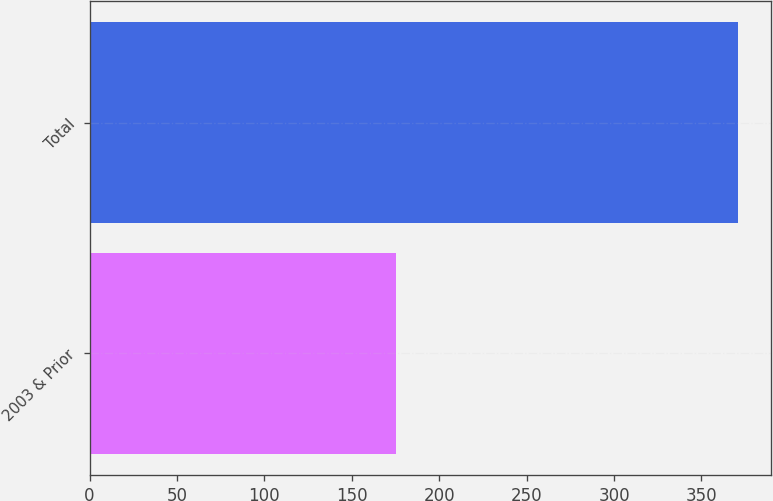<chart> <loc_0><loc_0><loc_500><loc_500><bar_chart><fcel>2003 & Prior<fcel>Total<nl><fcel>175.5<fcel>371.1<nl></chart> 